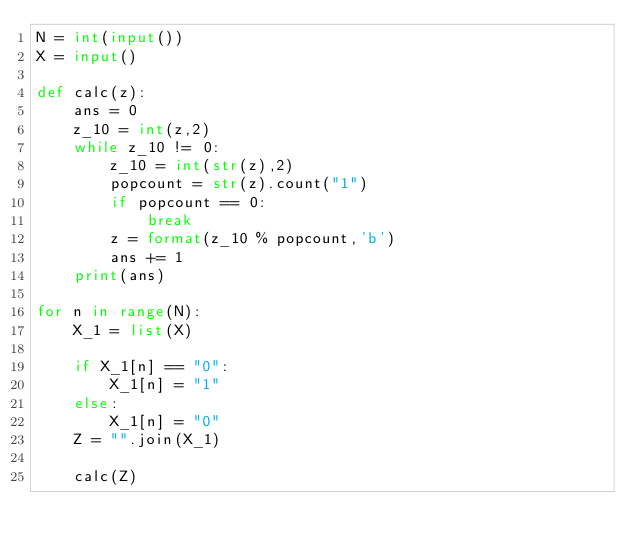Convert code to text. <code><loc_0><loc_0><loc_500><loc_500><_Python_>N = int(input())
X = input()

def calc(z):
    ans = 0
    z_10 = int(z,2)
    while z_10 != 0:
        z_10 = int(str(z),2)
        popcount = str(z).count("1")
        if popcount == 0:
            break
        z = format(z_10 % popcount,'b')
        ans += 1
    print(ans)
    
for n in range(N):
    X_1 = list(X)
    
    if X_1[n] == "0":
        X_1[n] = "1"
    else:
        X_1[n] = "0"
    Z = "".join(X_1)

    calc(Z)</code> 